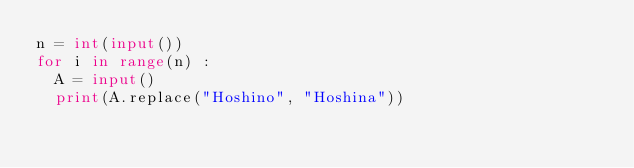<code> <loc_0><loc_0><loc_500><loc_500><_Python_>n = int(input())
for i in range(n) :
  A = input()
  print(A.replace("Hoshino", "Hoshina"))
</code> 